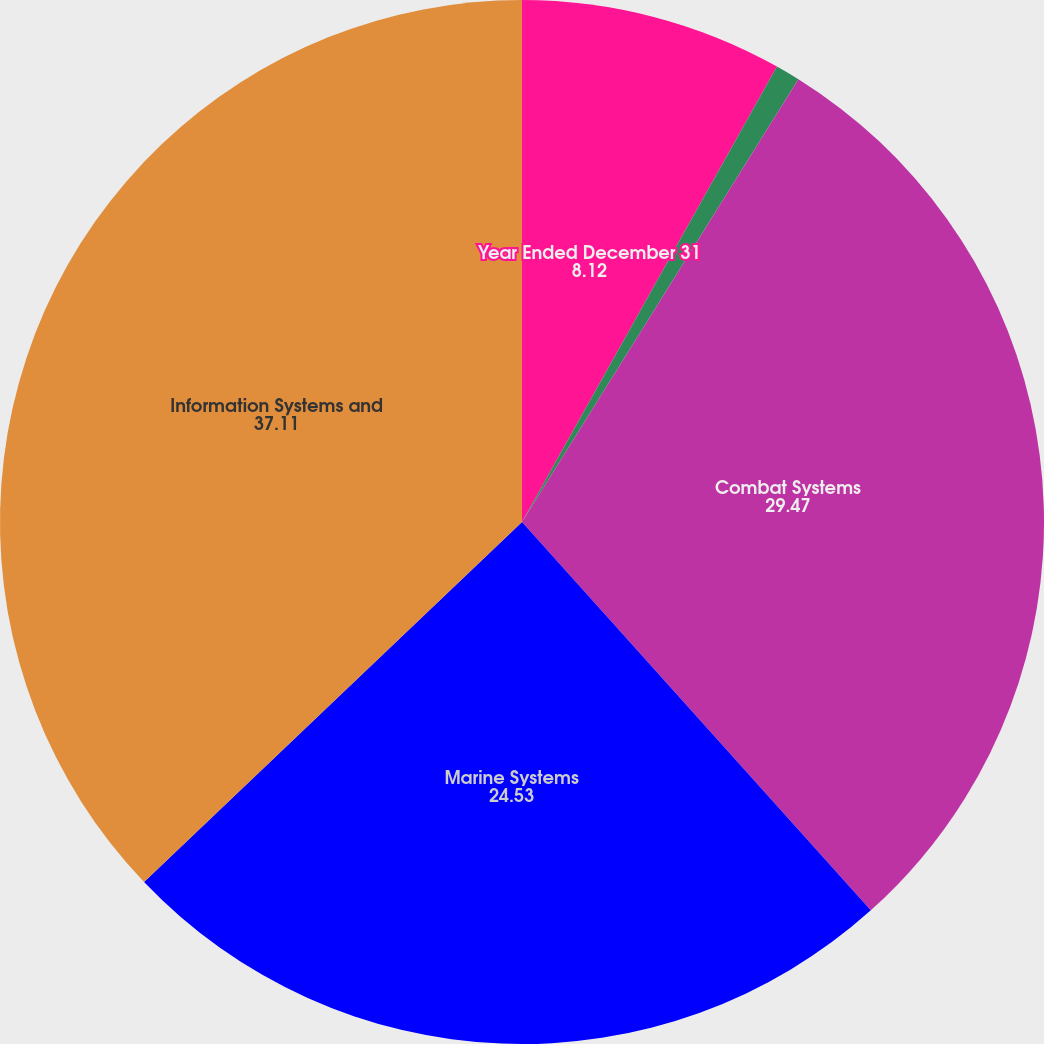Convert chart. <chart><loc_0><loc_0><loc_500><loc_500><pie_chart><fcel>Year Ended December 31<fcel>Aerospace<fcel>Combat Systems<fcel>Marine Systems<fcel>Information Systems and<nl><fcel>8.12%<fcel>0.76%<fcel>29.47%<fcel>24.53%<fcel>37.11%<nl></chart> 